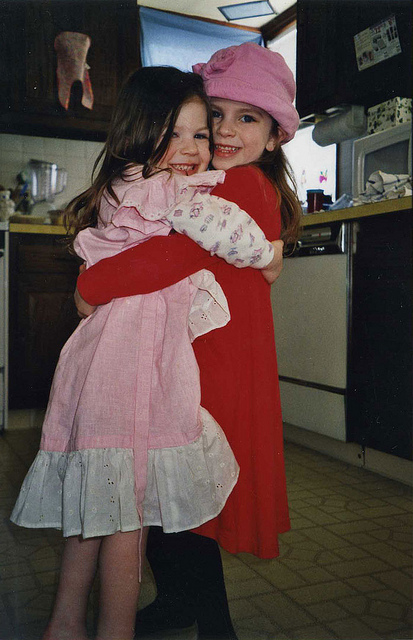<image>What is the color of the woman's jacket? I am not sure exactly what color the woman's jacket is. It can be seen as red or pink. What is the color of the woman's jacket? I am not sure what is the color of the woman's jacket. It can be seen red or pink. 